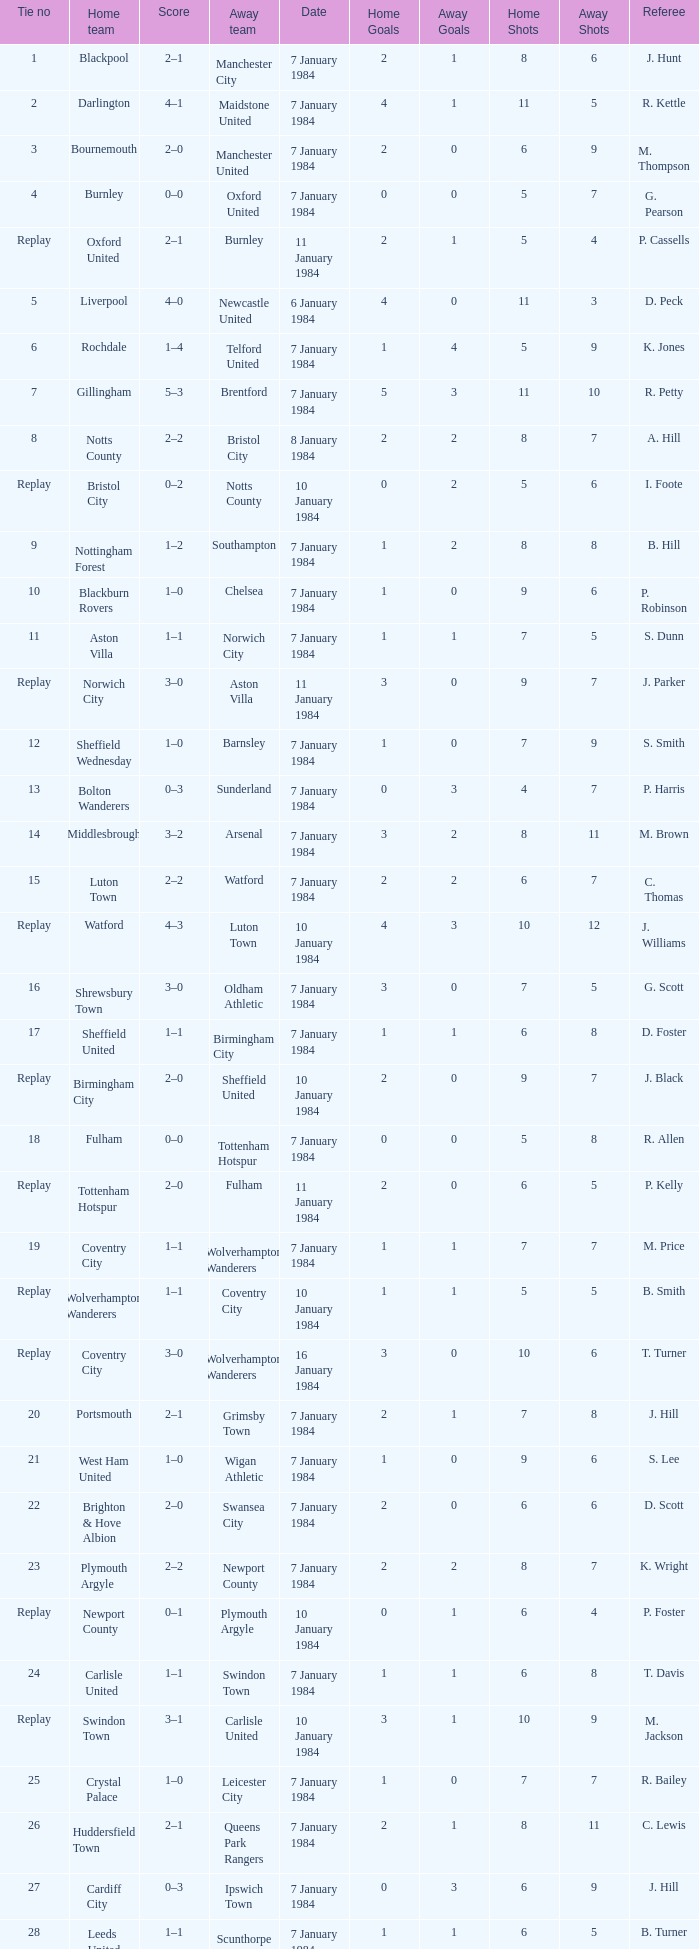Who was the away team with a tie of 14? Arsenal. 